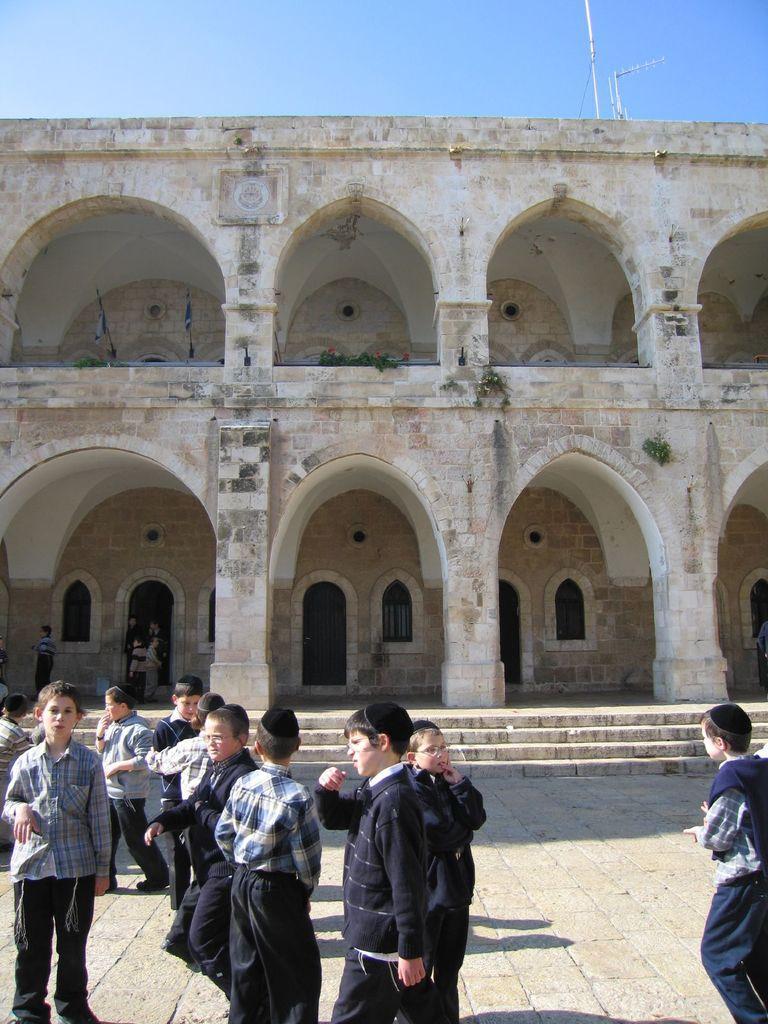Can you describe this image briefly? This picture shows building and we see couple of flags and we see boys standing and few of them wore caps on their heads and we see a blue cloudy sky. 